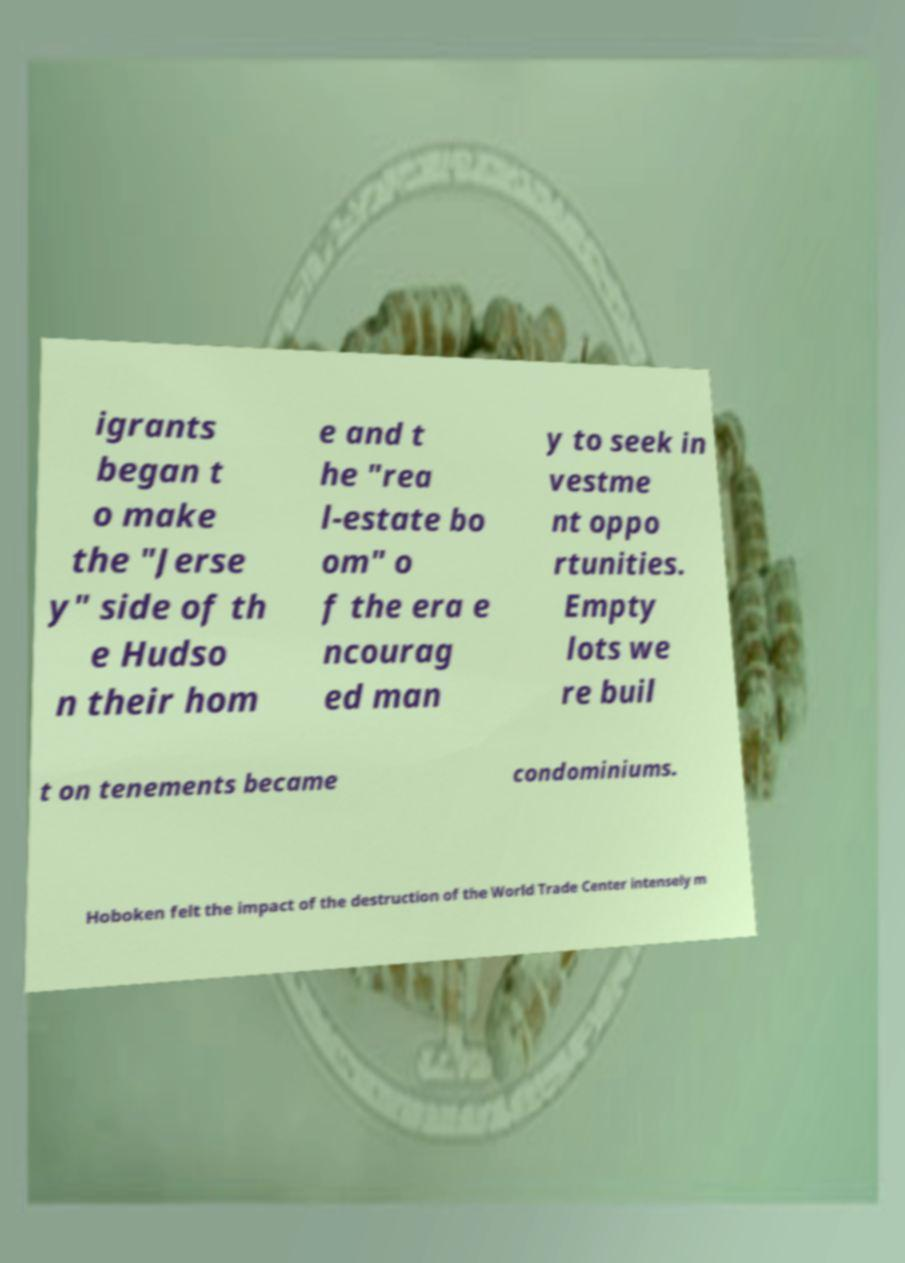Please identify and transcribe the text found in this image. igrants began t o make the "Jerse y" side of th e Hudso n their hom e and t he "rea l-estate bo om" o f the era e ncourag ed man y to seek in vestme nt oppo rtunities. Empty lots we re buil t on tenements became condominiums. Hoboken felt the impact of the destruction of the World Trade Center intensely m 